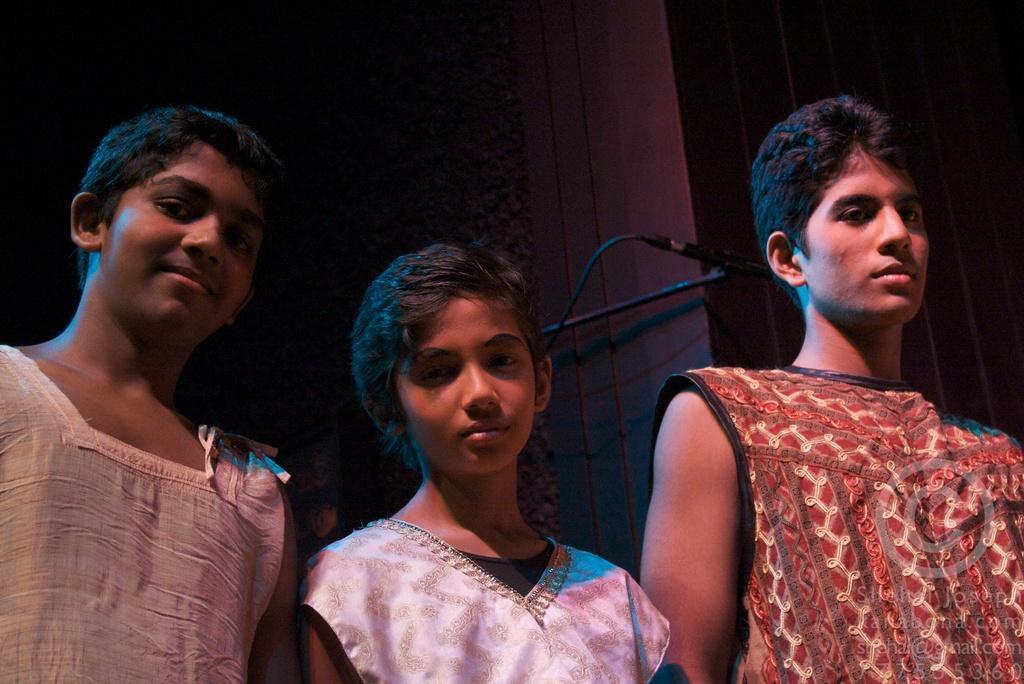Describe this image in one or two sentences. In the middle of the image three persons are standing and watching. Behind them we can see a microphone and wall. 